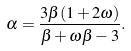Convert formula to latex. <formula><loc_0><loc_0><loc_500><loc_500>\alpha = \frac { 3 \beta ( 1 + 2 \omega ) } { \beta + \omega \beta - 3 } .</formula> 